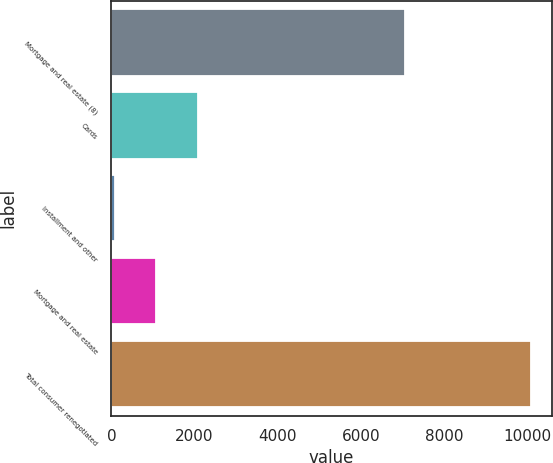Convert chart to OTSL. <chart><loc_0><loc_0><loc_500><loc_500><bar_chart><fcel>Mortgage and real estate (8)<fcel>Cards<fcel>Installment and other<fcel>Mortgage and real estate<fcel>Total consumer renegotiated<nl><fcel>7058<fcel>2080.4<fcel>79<fcel>1079.7<fcel>10086<nl></chart> 